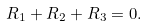<formula> <loc_0><loc_0><loc_500><loc_500>R _ { 1 } + R _ { 2 } + R _ { 3 } = 0 .</formula> 